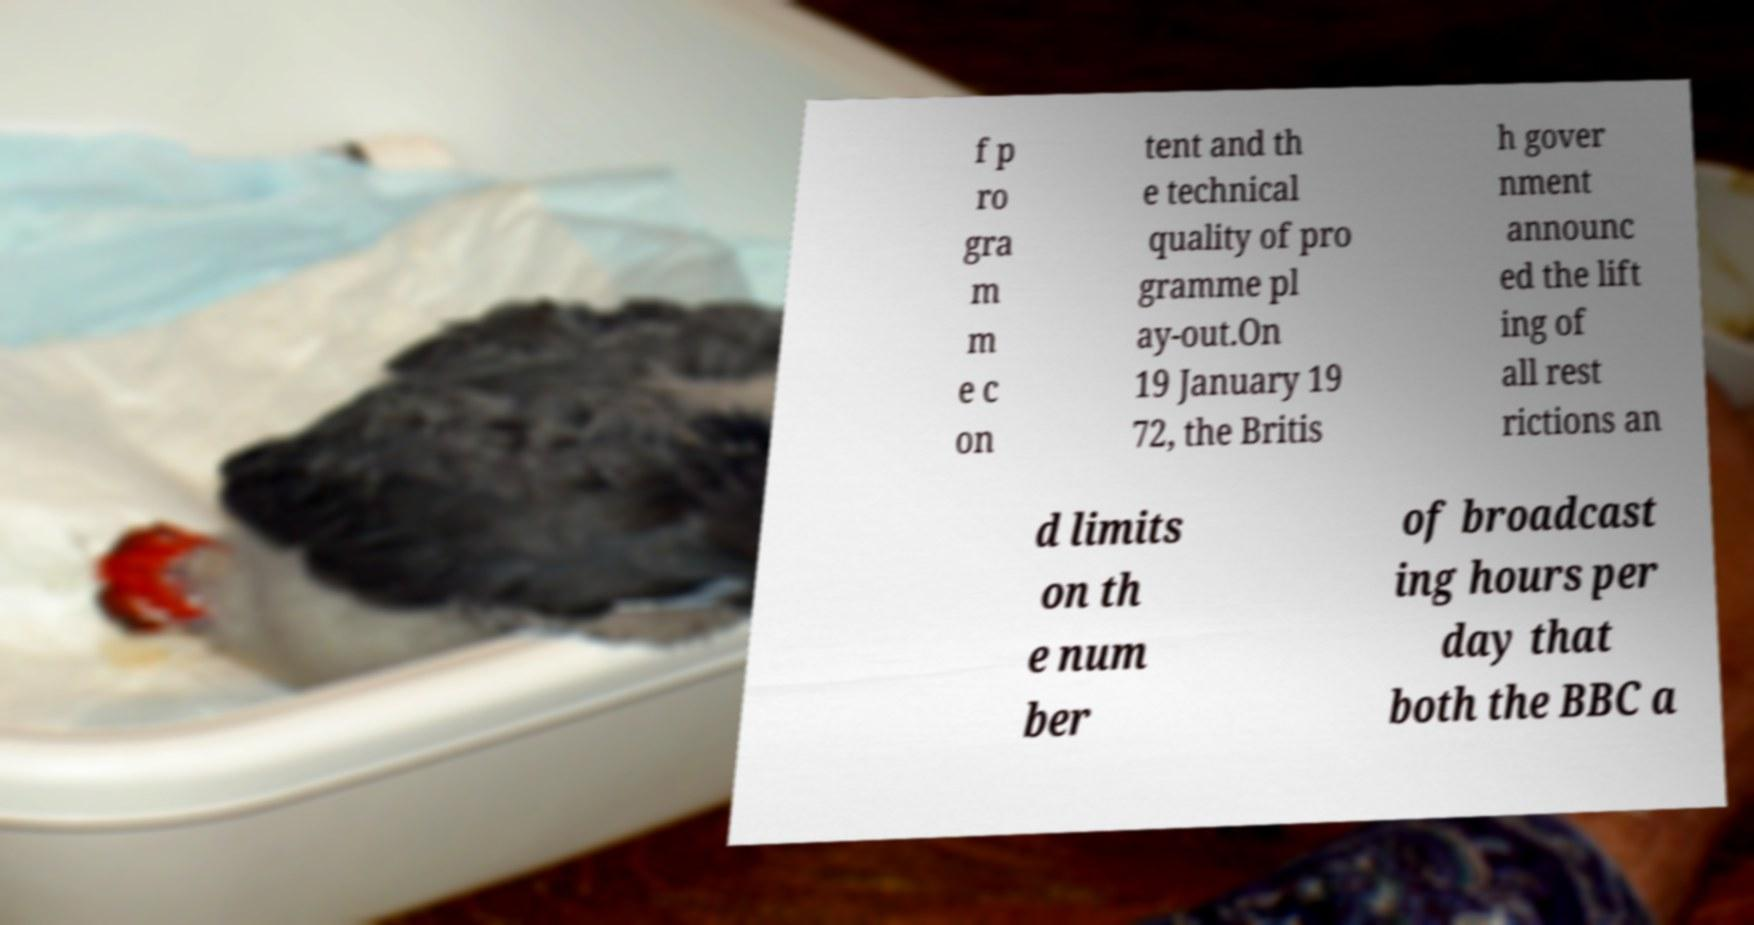For documentation purposes, I need the text within this image transcribed. Could you provide that? f p ro gra m m e c on tent and th e technical quality of pro gramme pl ay-out.On 19 January 19 72, the Britis h gover nment announc ed the lift ing of all rest rictions an d limits on th e num ber of broadcast ing hours per day that both the BBC a 